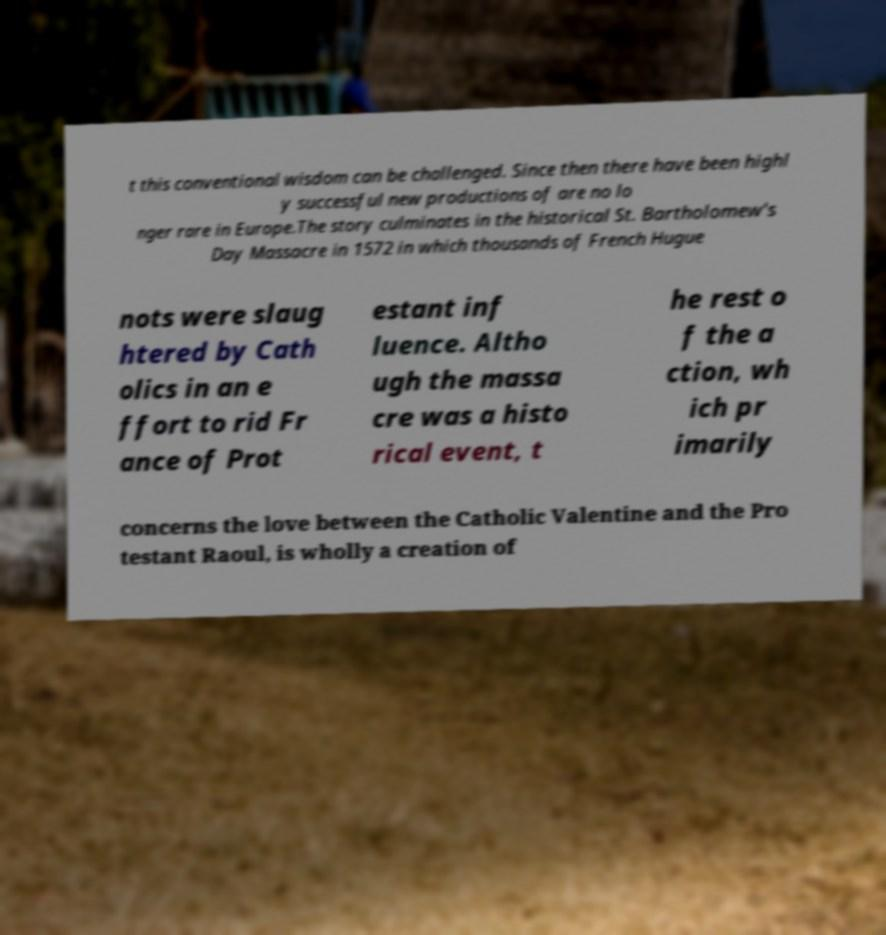Please identify and transcribe the text found in this image. t this conventional wisdom can be challenged. Since then there have been highl y successful new productions of are no lo nger rare in Europe.The story culminates in the historical St. Bartholomew's Day Massacre in 1572 in which thousands of French Hugue nots were slaug htered by Cath olics in an e ffort to rid Fr ance of Prot estant inf luence. Altho ugh the massa cre was a histo rical event, t he rest o f the a ction, wh ich pr imarily concerns the love between the Catholic Valentine and the Pro testant Raoul, is wholly a creation of 